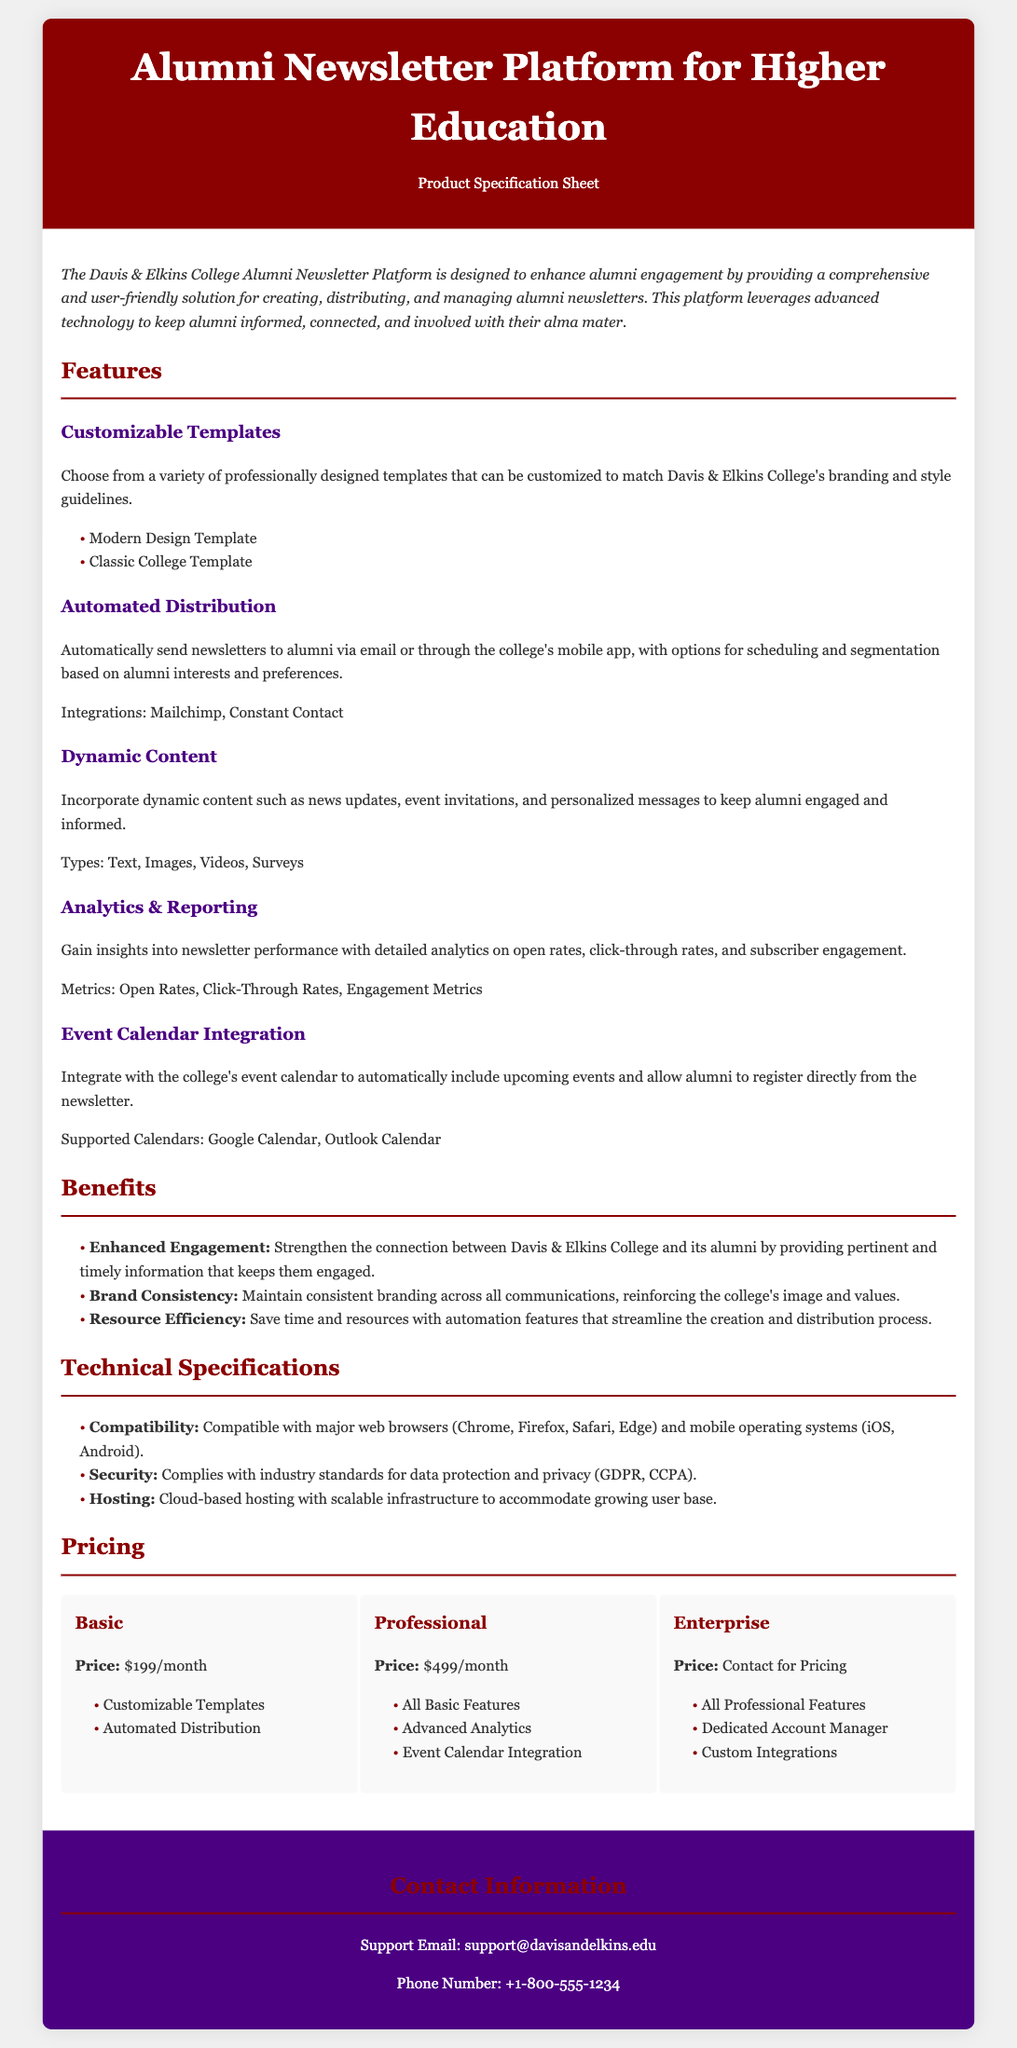What is the name of the platform? The platform is specifically referred to in the document as the "Alumni Newsletter Platform for Higher Education."
Answer: Alumni Newsletter Platform for Higher Education What is the price of the Basic plan? The document states the price for the Basic plan under the Pricing section.
Answer: $199/month Which feature allows for scheduling and segmentation? The feature that provides scheduling and segmentation options for alumni newsletters is "Automated Distribution."
Answer: Automated Distribution What types of dynamic content can be incorporated? The document lists various types of dynamic content that can be included in newsletters.
Answer: Text, Images, Videos, Surveys What is the primary benefit highlighted for alumni engagement? The document emphasizes a particular benefit related to enhancing alumni engagement.
Answer: Enhanced Engagement Who should be contacted for support? The contact information section of the document provides details on who to reach for support.
Answer: support@davisandelkins.edu What integrations are mentioned for automated distribution? The document lists integrations that can be utilized for automated newsletter distribution.
Answer: Mailchimp, Constant Contact How many plans are available? The Pricing section specifies the number of different plans offered by the platform.
Answer: Three 